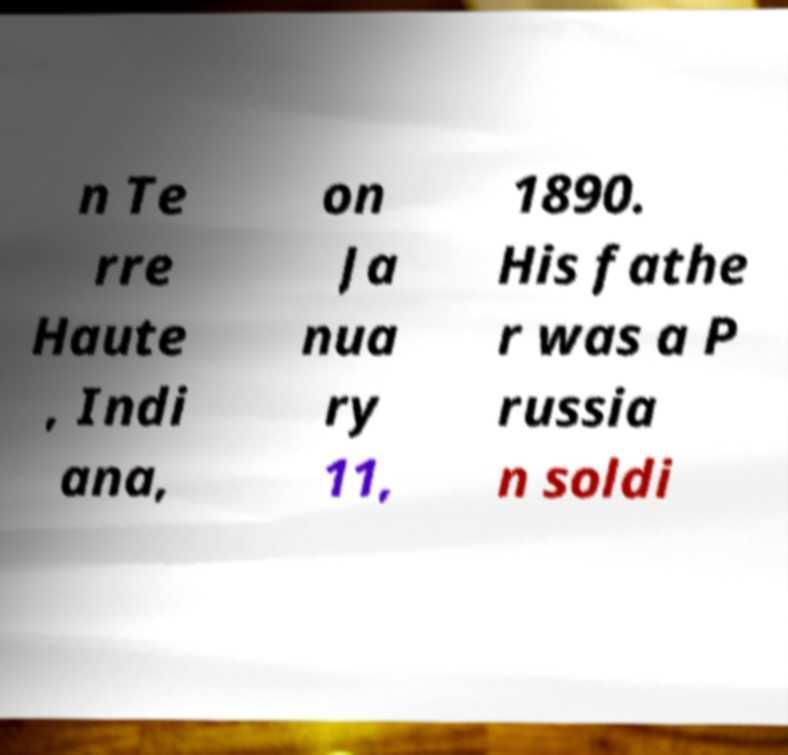Could you extract and type out the text from this image? n Te rre Haute , Indi ana, on Ja nua ry 11, 1890. His fathe r was a P russia n soldi 